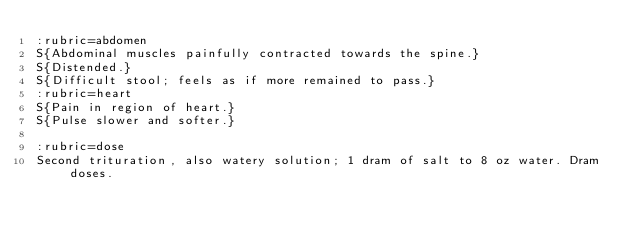Convert code to text. <code><loc_0><loc_0><loc_500><loc_500><_ObjectiveC_>:rubric=abdomen
S{Abdominal muscles painfully contracted towards the spine.}
S{Distended.}
S{Difficult stool; feels as if more remained to pass.}
:rubric=heart
S{Pain in region of heart.}
S{Pulse slower and softer.}

:rubric=dose
Second trituration, also watery solution; 1 dram of salt to 8 oz water. Dram doses.</code> 